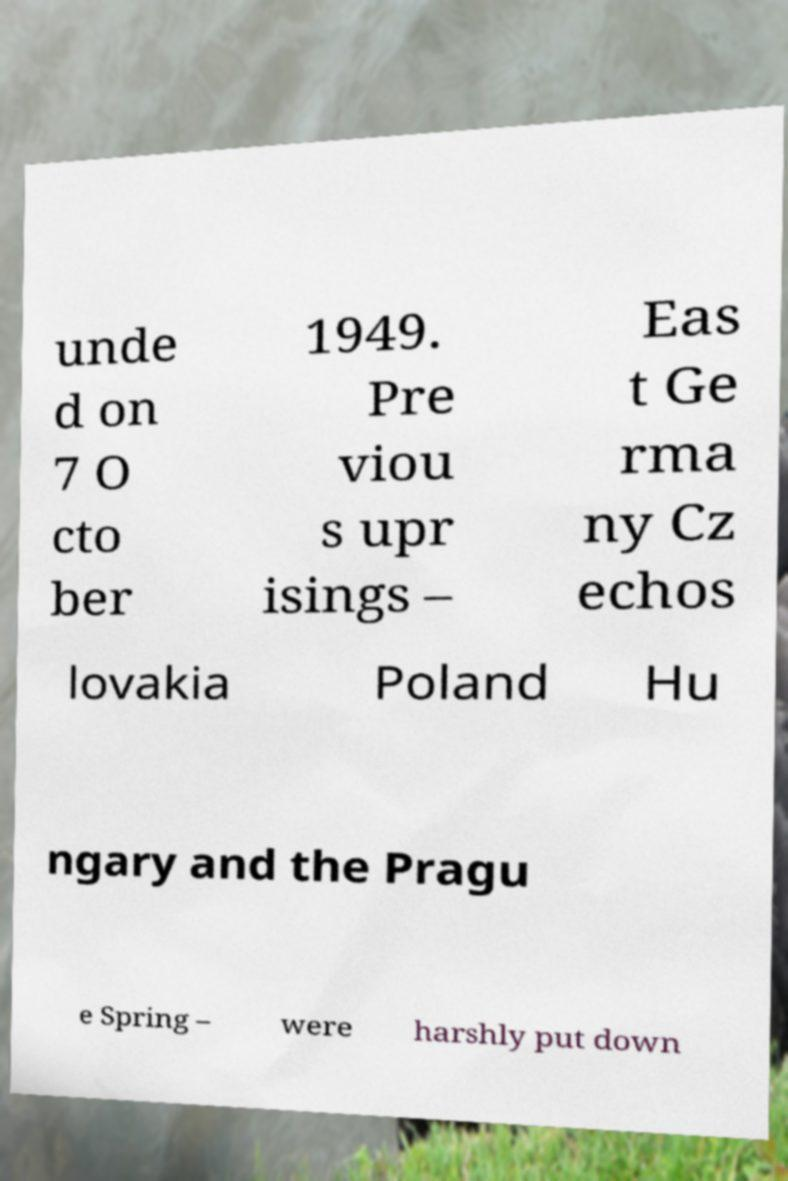Can you accurately transcribe the text from the provided image for me? unde d on 7 O cto ber 1949. Pre viou s upr isings – Eas t Ge rma ny Cz echos lovakia Poland Hu ngary and the Pragu e Spring – were harshly put down 